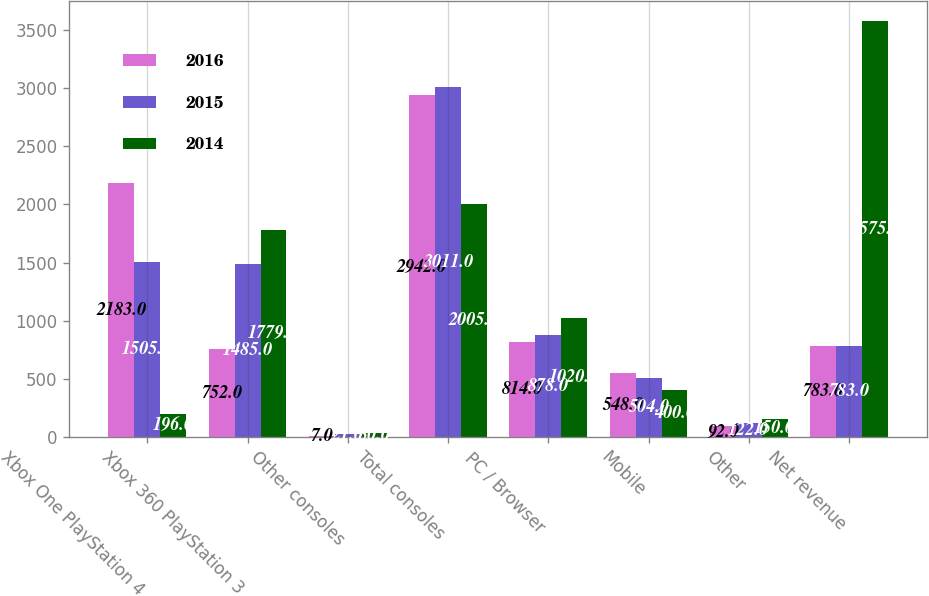<chart> <loc_0><loc_0><loc_500><loc_500><stacked_bar_chart><ecel><fcel>Xbox One PlayStation 4<fcel>Xbox 360 PlayStation 3<fcel>Other consoles<fcel>Total consoles<fcel>PC / Browser<fcel>Mobile<fcel>Other<fcel>Net revenue<nl><fcel>2016<fcel>2183<fcel>752<fcel>7<fcel>2942<fcel>814<fcel>548<fcel>92<fcel>783<nl><fcel>2015<fcel>1505<fcel>1485<fcel>21<fcel>3011<fcel>878<fcel>504<fcel>122<fcel>783<nl><fcel>2014<fcel>196<fcel>1779<fcel>30<fcel>2005<fcel>1020<fcel>400<fcel>150<fcel>3575<nl></chart> 